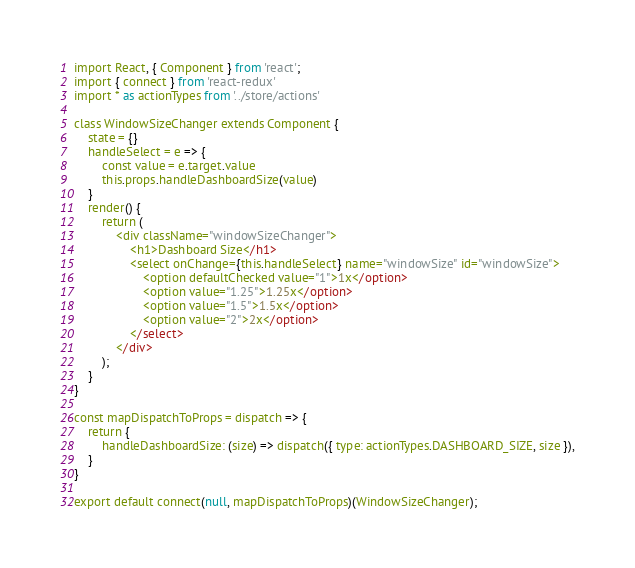<code> <loc_0><loc_0><loc_500><loc_500><_JavaScript_>import React, { Component } from 'react';
import { connect } from 'react-redux'
import * as actionTypes from '../store/actions'

class WindowSizeChanger extends Component {
    state = {}
    handleSelect = e => {
        const value = e.target.value
        this.props.handleDashboardSize(value)
    }
    render() {
        return (
            <div className="windowSizeChanger">
                <h1>Dashboard Size</h1>
                <select onChange={this.handleSelect} name="windowSize" id="windowSize">
                    <option defaultChecked value="1">1x</option>
                    <option value="1.25">1.25x</option>
                    <option value="1.5">1.5x</option>
                    <option value="2">2x</option>
                </select>
            </div>
        );
    }
}

const mapDispatchToProps = dispatch => {
    return {
        handleDashboardSize: (size) => dispatch({ type: actionTypes.DASHBOARD_SIZE, size }),
    }
}

export default connect(null, mapDispatchToProps)(WindowSizeChanger);</code> 